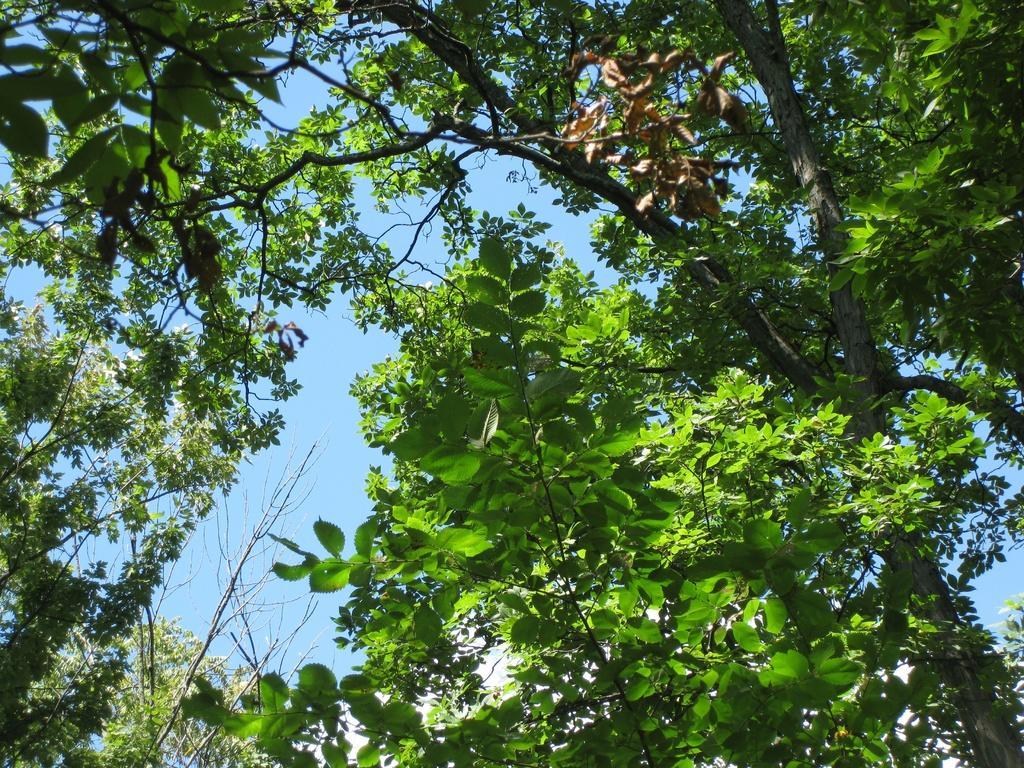In one or two sentences, can you explain what this image depicts? In this image there is plant, there is tree, there is sky, there are dried leaves. 